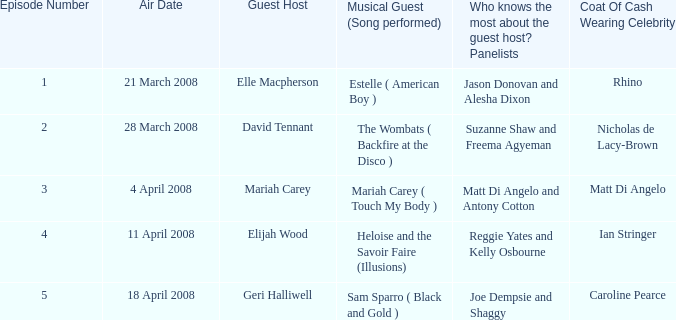Name the total number of episodes for coat of cash wearing celebrity is matt di angelo 1.0. Give me the full table as a dictionary. {'header': ['Episode Number', 'Air Date', 'Guest Host', 'Musical Guest (Song performed)', 'Who knows the most about the guest host? Panelists', 'Coat Of Cash Wearing Celebrity'], 'rows': [['1', '21 March 2008', 'Elle Macpherson', 'Estelle ( American Boy )', 'Jason Donovan and Alesha Dixon', 'Rhino'], ['2', '28 March 2008', 'David Tennant', 'The Wombats ( Backfire at the Disco )', 'Suzanne Shaw and Freema Agyeman', 'Nicholas de Lacy-Brown'], ['3', '4 April 2008', 'Mariah Carey', 'Mariah Carey ( Touch My Body )', 'Matt Di Angelo and Antony Cotton', 'Matt Di Angelo'], ['4', '11 April 2008', 'Elijah Wood', 'Heloise and the Savoir Faire (Illusions)', 'Reggie Yates and Kelly Osbourne', 'Ian Stringer'], ['5', '18 April 2008', 'Geri Halliwell', 'Sam Sparro ( Black and Gold )', 'Joe Dempsie and Shaggy', 'Caroline Pearce']]} 